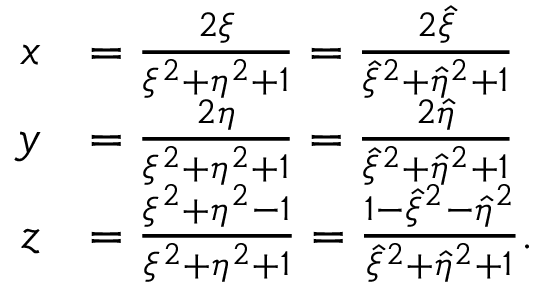<formula> <loc_0><loc_0><loc_500><loc_500>\begin{array} { r l } { x } & { = \frac { 2 \xi } { \xi ^ { 2 } + \eta ^ { 2 } + 1 } = \frac { 2 \hat { \xi } } { \hat { \xi } ^ { 2 } + \hat { \eta } ^ { 2 } + 1 } } \\ { y } & { = \frac { 2 \eta } { \xi ^ { 2 } + \eta ^ { 2 } + 1 } = \frac { 2 \hat { \eta } } { \hat { \xi } ^ { 2 } + \hat { \eta } ^ { 2 } + 1 } } \\ { z } & { = \frac { \xi ^ { 2 } + \eta ^ { 2 } - 1 } { \xi ^ { 2 } + \eta ^ { 2 } + 1 } = \frac { 1 - \hat { \xi } ^ { 2 } - \hat { \eta } ^ { 2 } } { \hat { \xi } ^ { 2 } + \hat { \eta } ^ { 2 } + 1 } . } \end{array}</formula> 